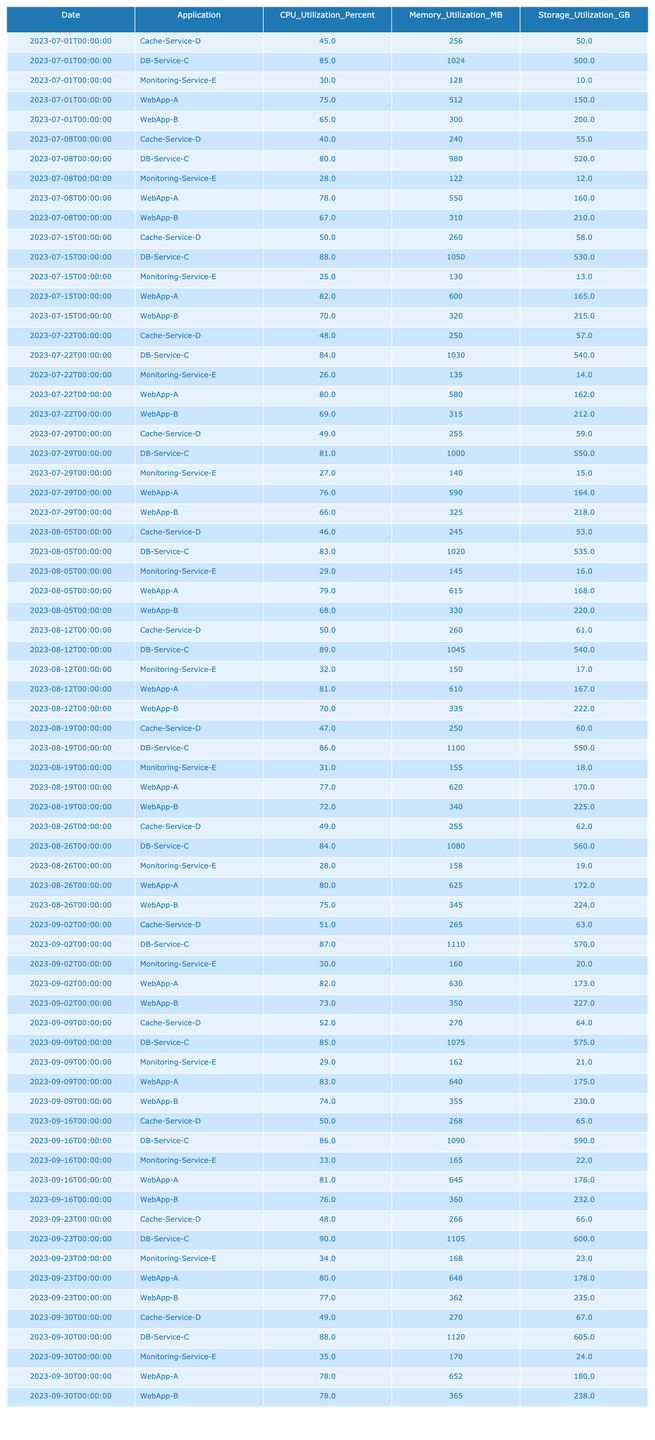What was the CPU utilization of DB-Service-C on August 12th? Looking at the table, I find the row for DB-Service-C on August 12th, where the CPU utilization percent is listed as 89.
Answer: 89 What is the highest recorded memory utilization for WebApp-A over the last quarter? By reviewing the memory utilization values for WebApp-A across all dates, the highest value is 652 MB on September 30th.
Answer: 652 MB Did Cache-Service-D ever reach a CPU utilization of over 50%? Examining the CPU utilization values for Cache-Service-D, the maximum observed value is 50% on July 15th, so it never exceeded 50%.
Answer: No What is the average storage utilization across all applications on September 9th? The storage utilization values for all applications on September 9th are 175, 230, 575, 64, and 21 GB. Summing these up gives 1065 GB, and dividing by 5 results in an average of 213 GB.
Answer: 213 GB Was there an increase or decrease in CPU utilization for WebApp-B from July 1st to September 30th? For WebApp-B on July 1st, CPU utilization was 65%, and on September 30th, it was 78%. Therefore, there was an increase of 13%.
Answer: Increase What was the trend in memory utilization for DB-Service-C during the quarter? I note that the memory utilization for DB-Service-C started at 1024 MB and ended at 1120 MB, with increasing values observed every week. Thus, the trend shows an overall increase in memory utilization over the quarter.
Answer: Increasing What was the total CPU utilization for WebApp-A throughout July? Assessing the CPU utilization values for WebApp-A during July, I find 75, 78, 82, 80, and 76%. Summing these values gives 391%, and dividing by 5 yields an average of 78.2%.
Answer: 78.2% Which application had the highest storage utilization on August 26th? Reviewing the storage utilization on August 26th, I see that DB-Service-C recorded the highest value of 560 GB.
Answer: DB-Service-C What was the change in memory utilization for Monitoring-Service-E from July 1st to September 30th? Monitoring-Service-E had memory utilization of 128 MB on July 1st and 170 MB on September 30th. The difference is 170 - 128 = 42 MB, indicating an increase.
Answer: Increase of 42 MB Is it true that every application's CPU utilization increased over the quarter? After comparing the CPU utilization values at the start and end of the quarter for each application, I see that some applications fluctuated downwards, so it is not true.
Answer: No What was the average memory utilization across all applications for the last data point? For the last data point on September 30th, memory utilizations are 652, 365, 1120, 270, and 170 MB. Summing these gives 2577 MB. Averaging over 5 applications yields 515.4 MB.
Answer: 515.4 MB 